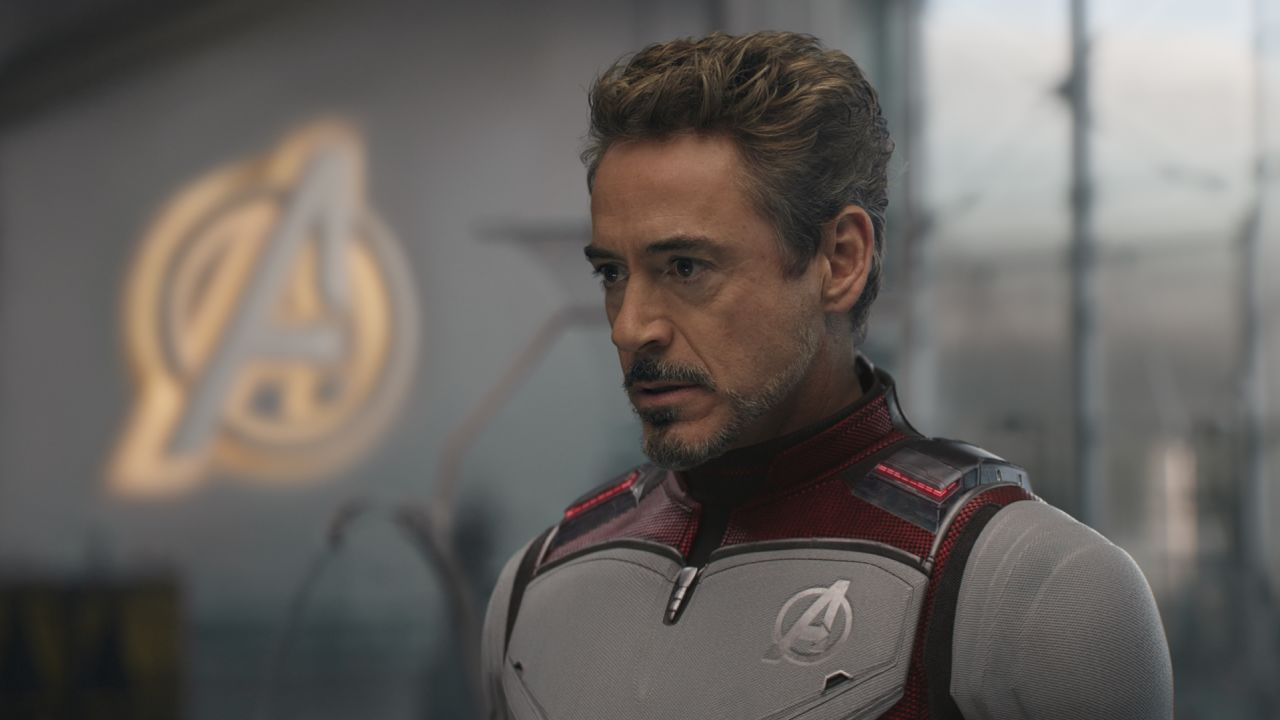What might Tony Stark be thinking about in this scene? Tony Stark's expression suggests a deep contemplation of upcoming challenges. He could be strategizing the next moves for the Avengers or reflecting on personal sacrifices that come with his role as a leader. 